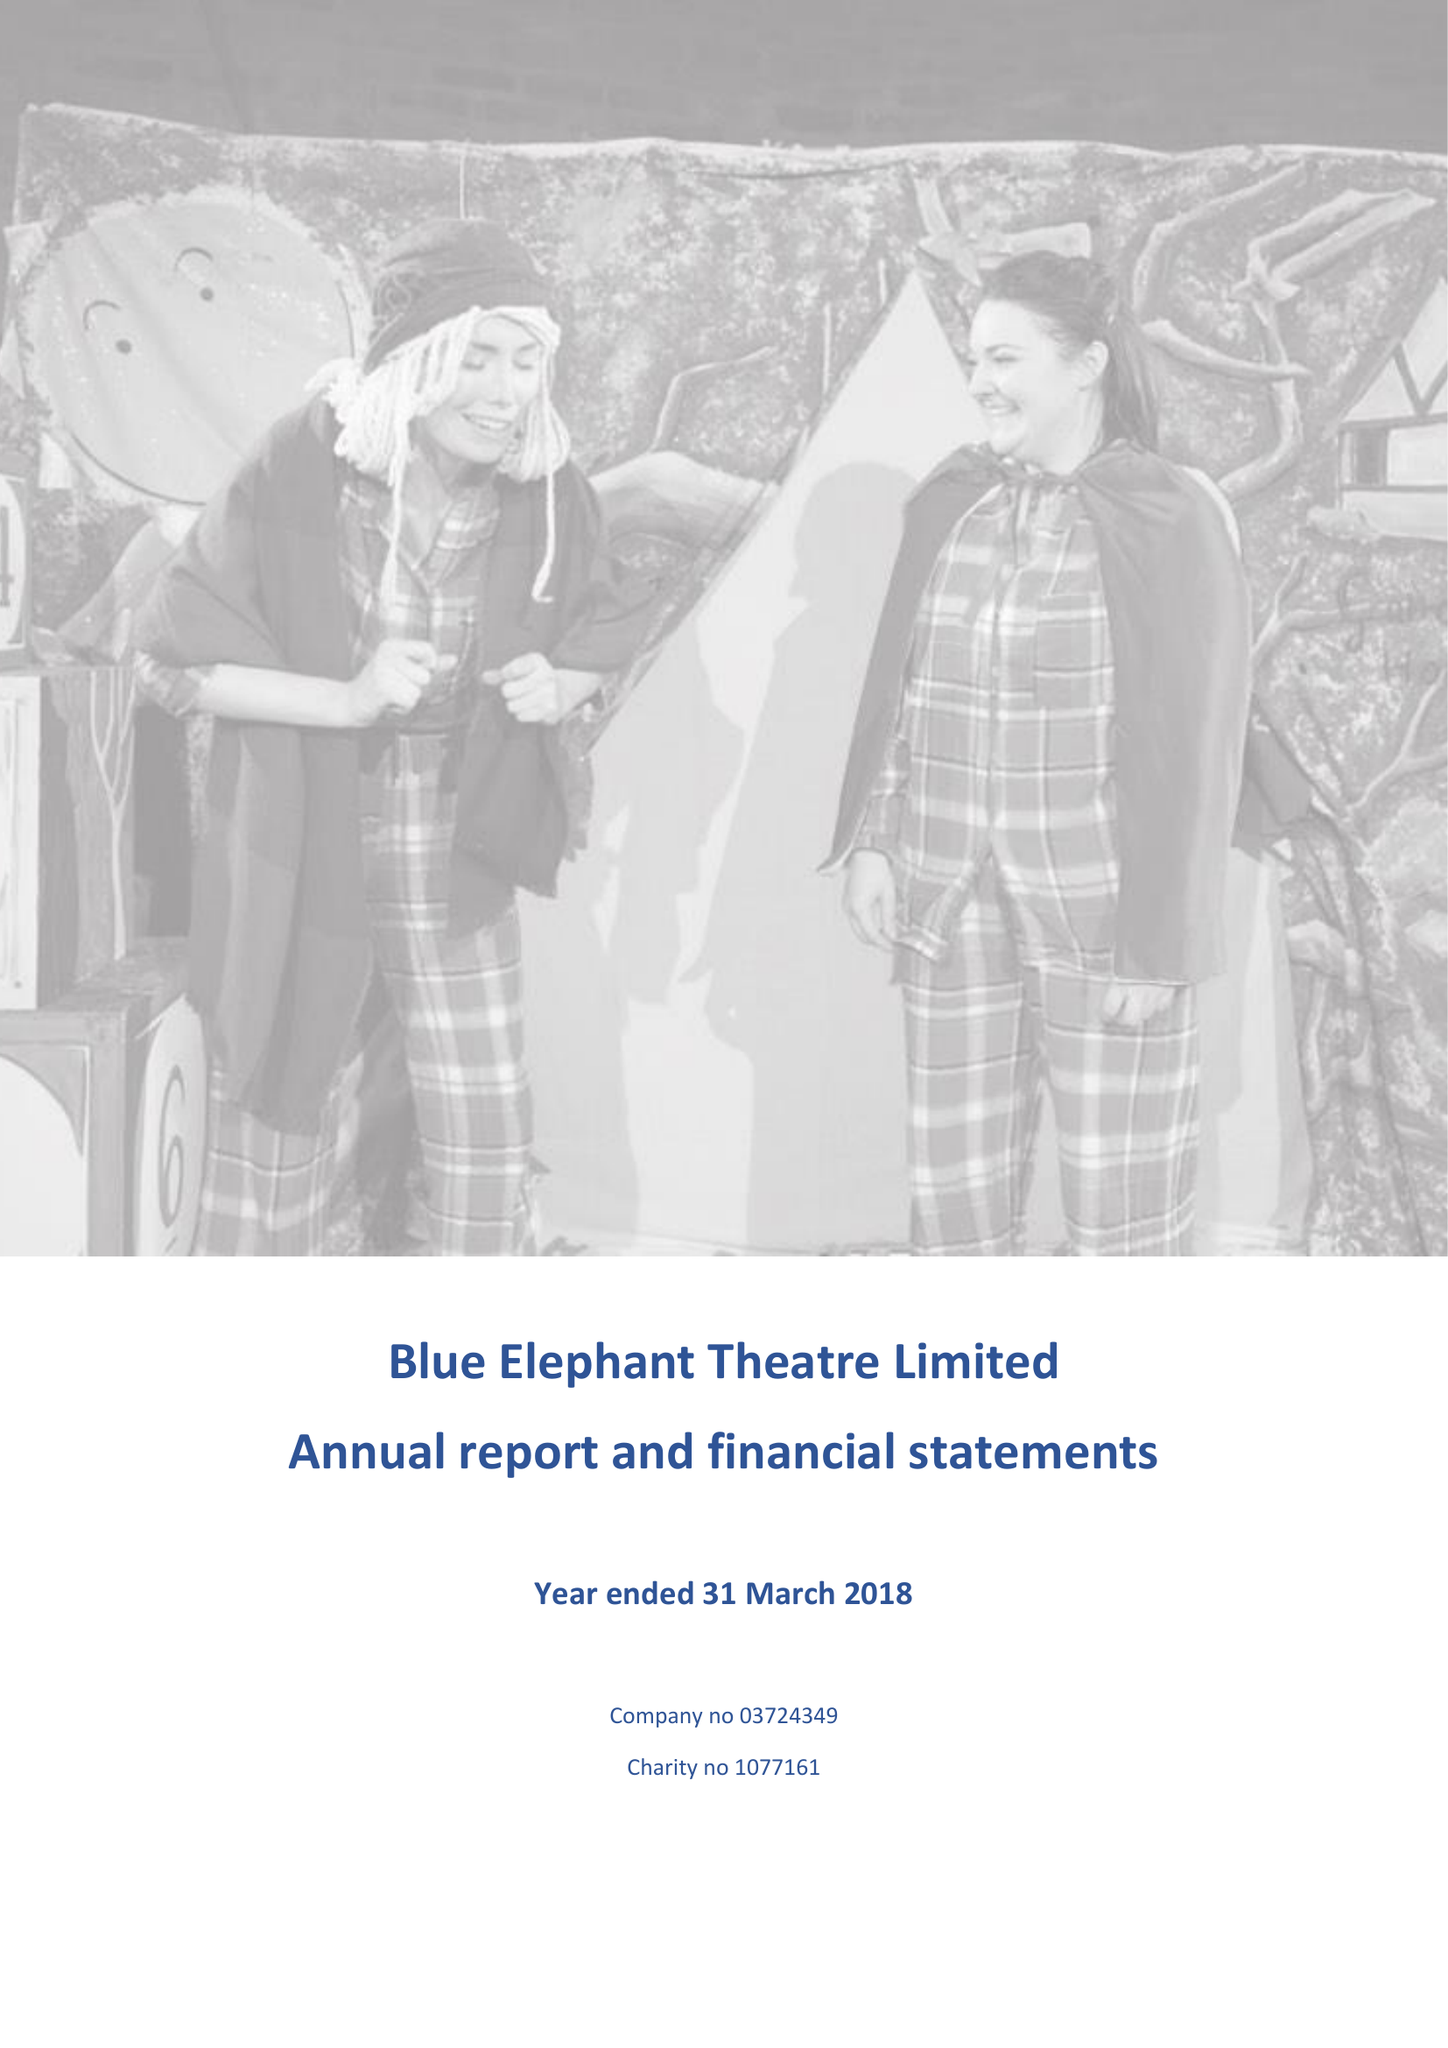What is the value for the address__postcode?
Answer the question using a single word or phrase. SE5 0XT 